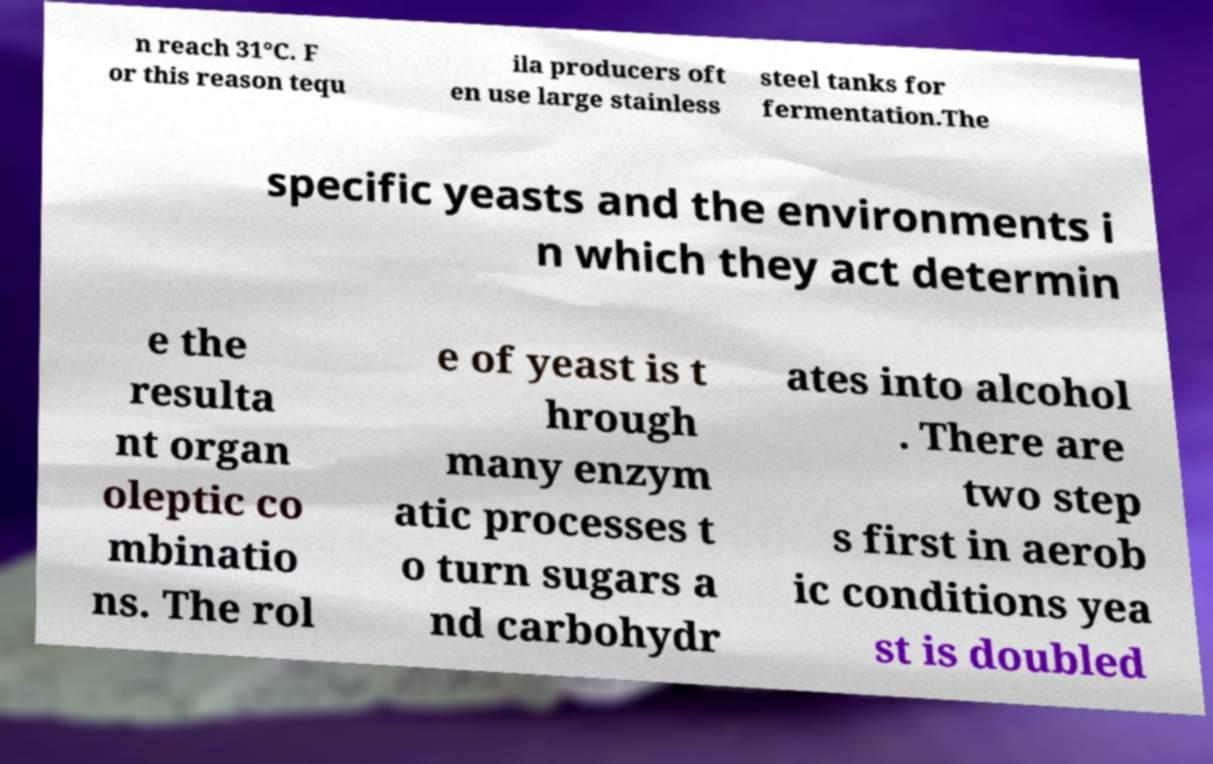Can you accurately transcribe the text from the provided image for me? n reach 31°C. F or this reason tequ ila producers oft en use large stainless steel tanks for fermentation.The specific yeasts and the environments i n which they act determin e the resulta nt organ oleptic co mbinatio ns. The rol e of yeast is t hrough many enzym atic processes t o turn sugars a nd carbohydr ates into alcohol . There are two step s first in aerob ic conditions yea st is doubled 